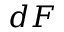Convert formula to latex. <formula><loc_0><loc_0><loc_500><loc_500>d F</formula> 